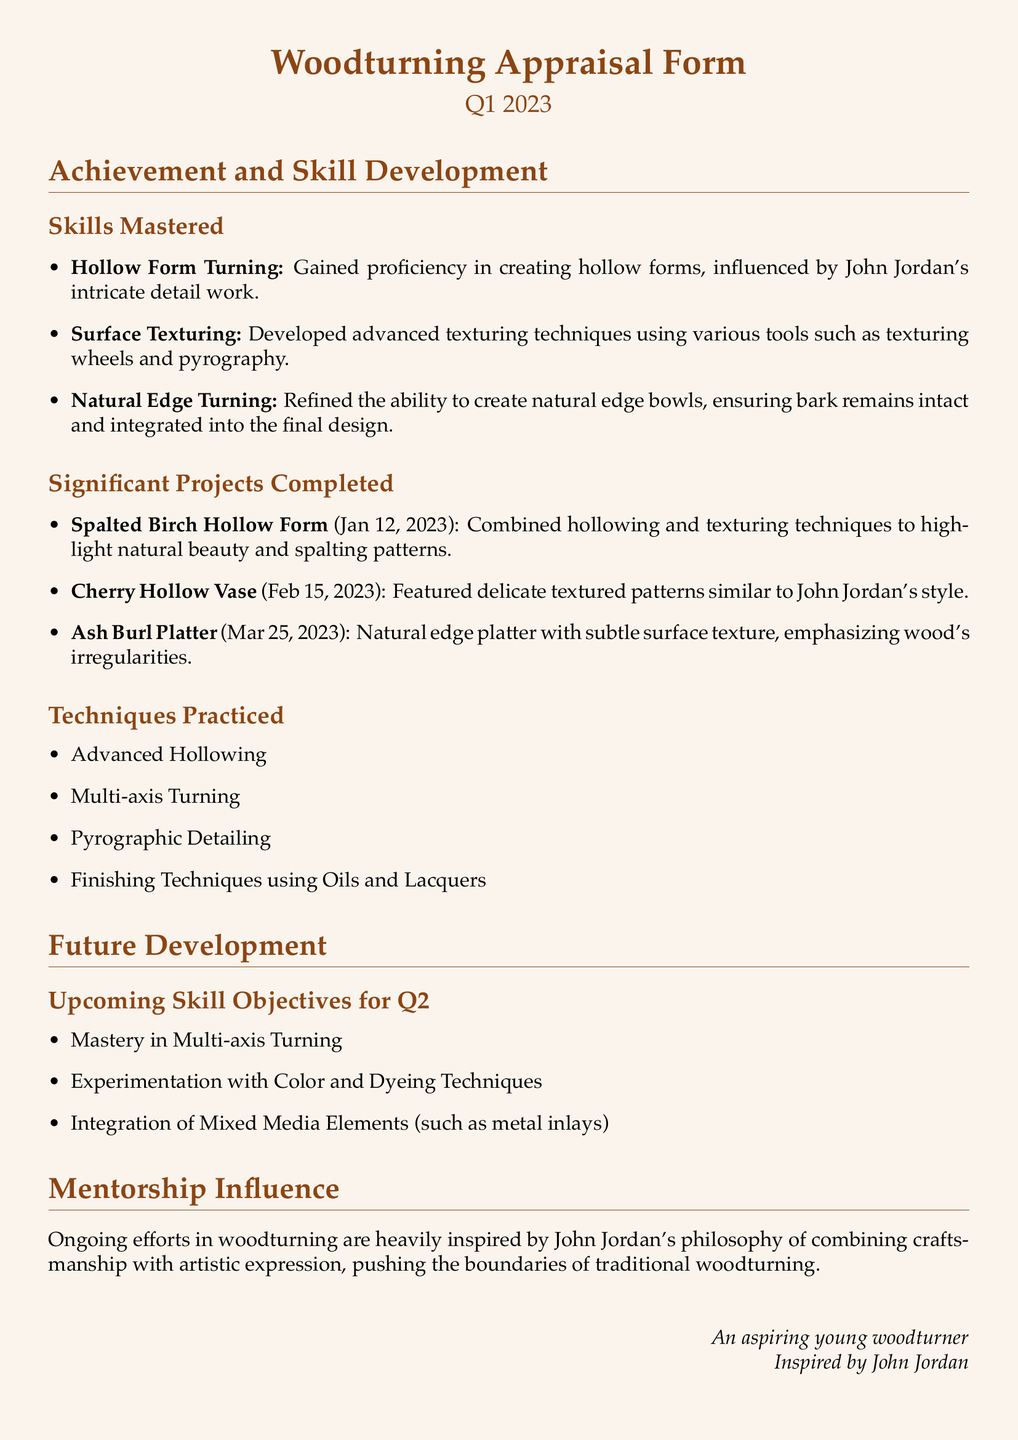What is the title of the document? The title of the document is presented prominently at the top, which is "Woodturning Appraisal Form."
Answer: Woodturning Appraisal Form What date is associated with Q1 2023 in the document? The document mentions "Q1 2023" as the period being appraised.
Answer: Q1 2023 How many significant projects were completed? There are three significant projects listed under the "Significant Projects Completed" section.
Answer: 3 What was one of the techniques mastered related to texture? The document lists "Surface Texturing" as one of the skills mastered in woodturning.
Answer: Surface Texturing Which wood type was used for the hollow form project completed on January 12, 2023? The hollow form project is specified as being made from "Spalted Birch."
Answer: Spalted Birch What is one upcoming skill objective for Q2 mentioned in the document? The document states "Mastery in Multi-axis Turning" as one of the upcoming skill objectives for the next quarter.
Answer: Mastery in Multi-axis Turning What is the style influence noted for the Cherry Hollow Vase? The influence noted is "similar to John Jordan's style" in the text about the Cherry Hollow Vase.
Answer: similar to John Jordan's style What type of platter was created on March 25, 2023? The type of platter created is referred to as an "Ash Burl Platter."
Answer: Ash Burl Platter Which artist's philosophy influences the woodturning work according to the document? The document attributes the influence to "John Jordan."
Answer: John Jordan 